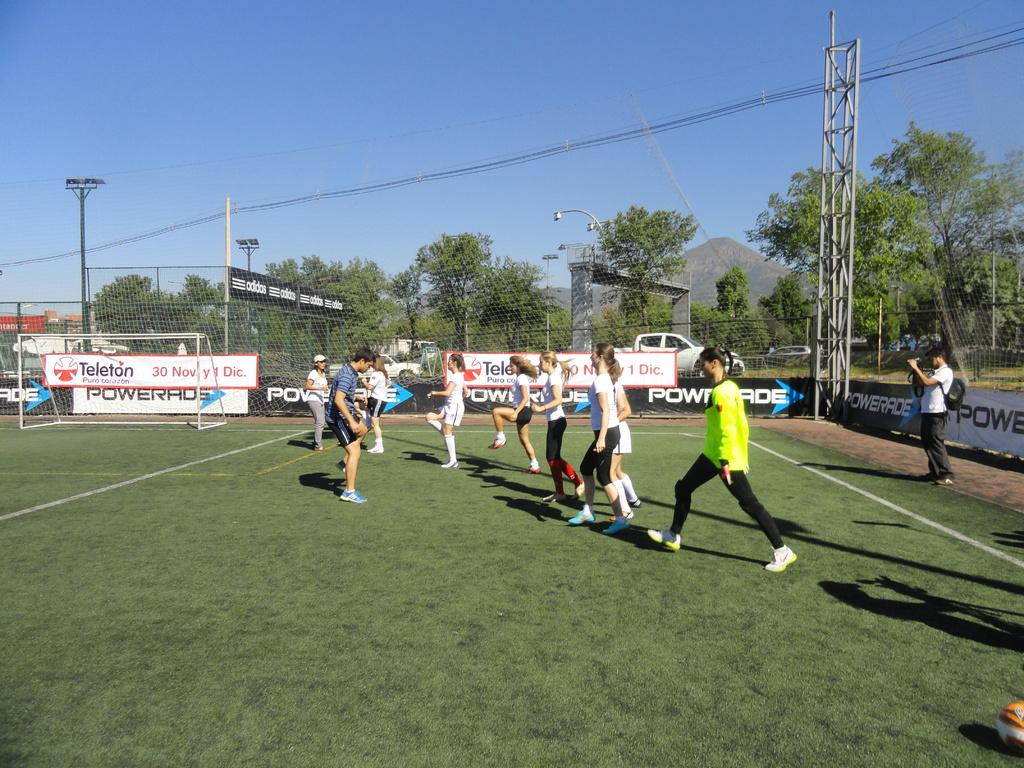<image>
Create a compact narrative representing the image presented. The soccer team at this field is sponsored by Powerade. 